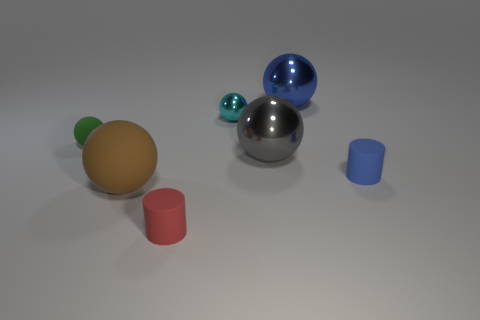Subtract all brown matte balls. How many balls are left? 4 Subtract all cyan spheres. How many spheres are left? 4 Subtract 2 balls. How many balls are left? 3 Add 2 large gray things. How many objects exist? 9 Subtract all brown spheres. Subtract all purple cubes. How many spheres are left? 4 Add 2 gray shiny balls. How many gray shiny balls are left? 3 Add 6 big gray metal things. How many big gray metal things exist? 7 Subtract 0 blue blocks. How many objects are left? 7 Subtract all cylinders. How many objects are left? 5 Subtract all tiny blue things. Subtract all big brown rubber spheres. How many objects are left? 5 